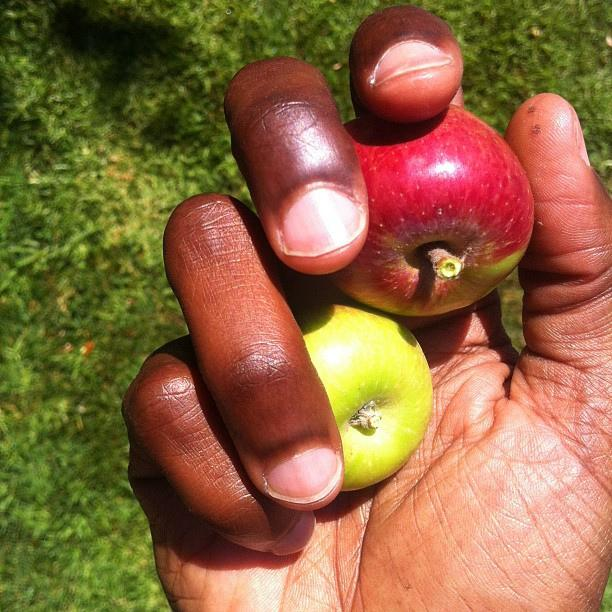What race is this person holding the apples?

Choices:
A) african
B) hispanic
C) east asian
D) white african 